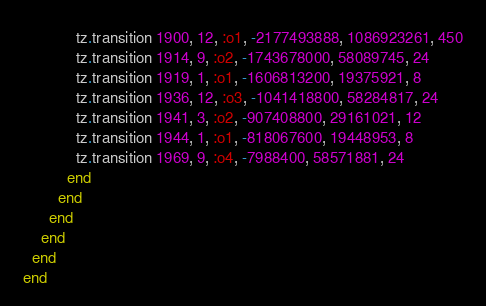Convert code to text. <code><loc_0><loc_0><loc_500><loc_500><_Ruby_>            tz.transition 1900, 12, :o1, -2177493888, 1086923261, 450
            tz.transition 1914, 9, :o2, -1743678000, 58089745, 24
            tz.transition 1919, 1, :o1, -1606813200, 19375921, 8
            tz.transition 1936, 12, :o3, -1041418800, 58284817, 24
            tz.transition 1941, 3, :o2, -907408800, 29161021, 12
            tz.transition 1944, 1, :o1, -818067600, 19448953, 8
            tz.transition 1969, 9, :o4, -7988400, 58571881, 24
          end
        end
      end
    end
  end
end
</code> 